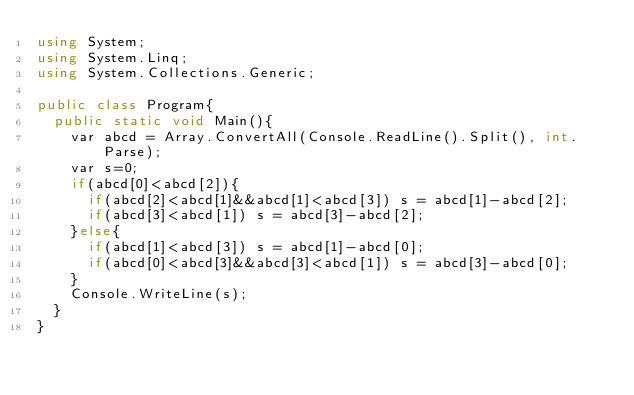<code> <loc_0><loc_0><loc_500><loc_500><_C#_>using System;
using System.Linq;
using System.Collections.Generic;

public class Program{
  public static void Main(){
    var abcd = Array.ConvertAll(Console.ReadLine().Split(), int.Parse);
    var s=0;
    if(abcd[0]<abcd[2]){
      if(abcd[2]<abcd[1]&&abcd[1]<abcd[3]) s = abcd[1]-abcd[2];
      if(abcd[3]<abcd[1]) s = abcd[3]-abcd[2];
    }else{
      if(abcd[1]<abcd[3]) s = abcd[1]-abcd[0];
      if(abcd[0]<abcd[3]&&abcd[3]<abcd[1]) s = abcd[3]-abcd[0];
    }
    Console.WriteLine(s);
  }
}
</code> 